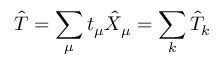Convert formula to latex. <formula><loc_0><loc_0><loc_500><loc_500>\hat { T } = \sum _ { \mu } t _ { \mu } \hat { X } _ { \mu } = \sum _ { k } \hat { T } _ { k }</formula> 